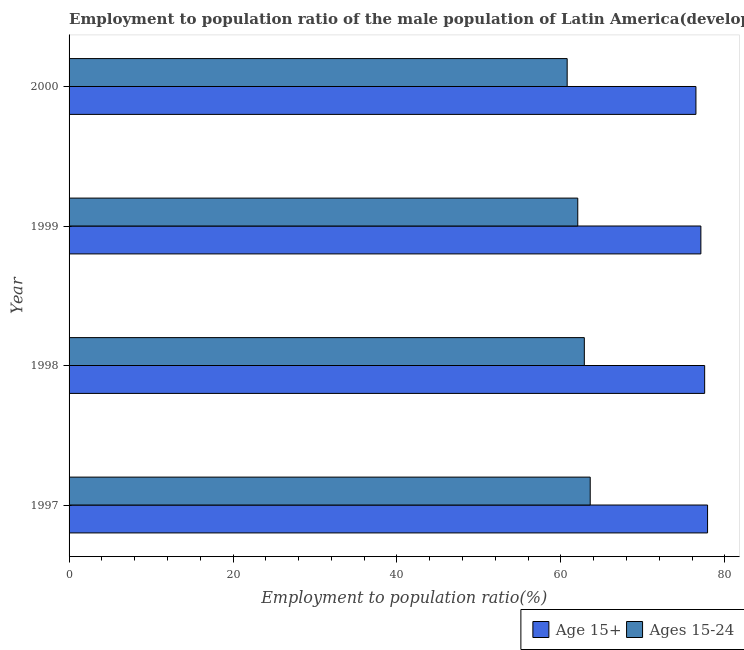How many different coloured bars are there?
Offer a terse response. 2. How many groups of bars are there?
Offer a terse response. 4. Are the number of bars per tick equal to the number of legend labels?
Offer a terse response. Yes. Are the number of bars on each tick of the Y-axis equal?
Your answer should be very brief. Yes. How many bars are there on the 4th tick from the top?
Give a very brief answer. 2. In how many cases, is the number of bars for a given year not equal to the number of legend labels?
Ensure brevity in your answer.  0. What is the employment to population ratio(age 15-24) in 1998?
Offer a terse response. 62.85. Across all years, what is the maximum employment to population ratio(age 15+)?
Ensure brevity in your answer.  77.89. Across all years, what is the minimum employment to population ratio(age 15-24)?
Offer a very short reply. 60.76. In which year was the employment to population ratio(age 15+) maximum?
Make the answer very short. 1997. What is the total employment to population ratio(age 15+) in the graph?
Provide a succinct answer. 308.96. What is the difference between the employment to population ratio(age 15+) in 1998 and that in 2000?
Keep it short and to the point. 1.06. What is the difference between the employment to population ratio(age 15+) in 1998 and the employment to population ratio(age 15-24) in 1999?
Give a very brief answer. 15.48. What is the average employment to population ratio(age 15-24) per year?
Offer a terse response. 62.31. In the year 1998, what is the difference between the employment to population ratio(age 15-24) and employment to population ratio(age 15+)?
Offer a terse response. -14.68. Is the employment to population ratio(age 15+) in 1997 less than that in 1998?
Give a very brief answer. No. What is the difference between the highest and the second highest employment to population ratio(age 15+)?
Your answer should be very brief. 0.36. What is the difference between the highest and the lowest employment to population ratio(age 15-24)?
Keep it short and to the point. 2.81. In how many years, is the employment to population ratio(age 15+) greater than the average employment to population ratio(age 15+) taken over all years?
Offer a very short reply. 2. What does the 1st bar from the top in 1999 represents?
Keep it short and to the point. Ages 15-24. What does the 1st bar from the bottom in 1997 represents?
Your response must be concise. Age 15+. How many years are there in the graph?
Your answer should be very brief. 4. Are the values on the major ticks of X-axis written in scientific E-notation?
Provide a short and direct response. No. Does the graph contain any zero values?
Provide a succinct answer. No. How are the legend labels stacked?
Give a very brief answer. Horizontal. What is the title of the graph?
Provide a succinct answer. Employment to population ratio of the male population of Latin America(developing only) for different age-groups. Does "Drinking water services" appear as one of the legend labels in the graph?
Provide a succinct answer. No. What is the label or title of the X-axis?
Offer a very short reply. Employment to population ratio(%). What is the Employment to population ratio(%) in Age 15+ in 1997?
Make the answer very short. 77.89. What is the Employment to population ratio(%) of Ages 15-24 in 1997?
Offer a very short reply. 63.57. What is the Employment to population ratio(%) of Age 15+ in 1998?
Provide a succinct answer. 77.53. What is the Employment to population ratio(%) of Ages 15-24 in 1998?
Keep it short and to the point. 62.85. What is the Employment to population ratio(%) in Age 15+ in 1999?
Your answer should be compact. 77.07. What is the Employment to population ratio(%) in Ages 15-24 in 1999?
Keep it short and to the point. 62.05. What is the Employment to population ratio(%) in Age 15+ in 2000?
Give a very brief answer. 76.47. What is the Employment to population ratio(%) in Ages 15-24 in 2000?
Your response must be concise. 60.76. Across all years, what is the maximum Employment to population ratio(%) in Age 15+?
Your answer should be compact. 77.89. Across all years, what is the maximum Employment to population ratio(%) in Ages 15-24?
Provide a short and direct response. 63.57. Across all years, what is the minimum Employment to population ratio(%) of Age 15+?
Give a very brief answer. 76.47. Across all years, what is the minimum Employment to population ratio(%) of Ages 15-24?
Offer a very short reply. 60.76. What is the total Employment to population ratio(%) in Age 15+ in the graph?
Your response must be concise. 308.96. What is the total Employment to population ratio(%) in Ages 15-24 in the graph?
Offer a very short reply. 249.24. What is the difference between the Employment to population ratio(%) of Age 15+ in 1997 and that in 1998?
Ensure brevity in your answer.  0.36. What is the difference between the Employment to population ratio(%) of Ages 15-24 in 1997 and that in 1998?
Ensure brevity in your answer.  0.72. What is the difference between the Employment to population ratio(%) in Age 15+ in 1997 and that in 1999?
Your answer should be compact. 0.82. What is the difference between the Employment to population ratio(%) of Ages 15-24 in 1997 and that in 1999?
Provide a succinct answer. 1.52. What is the difference between the Employment to population ratio(%) in Age 15+ in 1997 and that in 2000?
Your answer should be compact. 1.42. What is the difference between the Employment to population ratio(%) of Ages 15-24 in 1997 and that in 2000?
Your answer should be very brief. 2.81. What is the difference between the Employment to population ratio(%) of Age 15+ in 1998 and that in 1999?
Provide a short and direct response. 0.46. What is the difference between the Employment to population ratio(%) in Ages 15-24 in 1998 and that in 1999?
Make the answer very short. 0.8. What is the difference between the Employment to population ratio(%) in Ages 15-24 in 1998 and that in 2000?
Offer a terse response. 2.09. What is the difference between the Employment to population ratio(%) in Age 15+ in 1999 and that in 2000?
Keep it short and to the point. 0.6. What is the difference between the Employment to population ratio(%) in Ages 15-24 in 1999 and that in 2000?
Keep it short and to the point. 1.29. What is the difference between the Employment to population ratio(%) of Age 15+ in 1997 and the Employment to population ratio(%) of Ages 15-24 in 1998?
Your response must be concise. 15.03. What is the difference between the Employment to population ratio(%) of Age 15+ in 1997 and the Employment to population ratio(%) of Ages 15-24 in 1999?
Provide a short and direct response. 15.83. What is the difference between the Employment to population ratio(%) of Age 15+ in 1997 and the Employment to population ratio(%) of Ages 15-24 in 2000?
Give a very brief answer. 17.13. What is the difference between the Employment to population ratio(%) of Age 15+ in 1998 and the Employment to population ratio(%) of Ages 15-24 in 1999?
Offer a terse response. 15.48. What is the difference between the Employment to population ratio(%) of Age 15+ in 1998 and the Employment to population ratio(%) of Ages 15-24 in 2000?
Provide a short and direct response. 16.77. What is the difference between the Employment to population ratio(%) in Age 15+ in 1999 and the Employment to population ratio(%) in Ages 15-24 in 2000?
Provide a short and direct response. 16.31. What is the average Employment to population ratio(%) in Age 15+ per year?
Provide a succinct answer. 77.24. What is the average Employment to population ratio(%) in Ages 15-24 per year?
Offer a very short reply. 62.31. In the year 1997, what is the difference between the Employment to population ratio(%) in Age 15+ and Employment to population ratio(%) in Ages 15-24?
Offer a very short reply. 14.31. In the year 1998, what is the difference between the Employment to population ratio(%) of Age 15+ and Employment to population ratio(%) of Ages 15-24?
Keep it short and to the point. 14.68. In the year 1999, what is the difference between the Employment to population ratio(%) of Age 15+ and Employment to population ratio(%) of Ages 15-24?
Give a very brief answer. 15.02. In the year 2000, what is the difference between the Employment to population ratio(%) in Age 15+ and Employment to population ratio(%) in Ages 15-24?
Keep it short and to the point. 15.71. What is the ratio of the Employment to population ratio(%) in Age 15+ in 1997 to that in 1998?
Your answer should be very brief. 1. What is the ratio of the Employment to population ratio(%) in Ages 15-24 in 1997 to that in 1998?
Provide a short and direct response. 1.01. What is the ratio of the Employment to population ratio(%) of Age 15+ in 1997 to that in 1999?
Ensure brevity in your answer.  1.01. What is the ratio of the Employment to population ratio(%) in Ages 15-24 in 1997 to that in 1999?
Your answer should be compact. 1.02. What is the ratio of the Employment to population ratio(%) in Age 15+ in 1997 to that in 2000?
Your answer should be compact. 1.02. What is the ratio of the Employment to population ratio(%) in Ages 15-24 in 1997 to that in 2000?
Offer a terse response. 1.05. What is the ratio of the Employment to population ratio(%) in Age 15+ in 1998 to that in 1999?
Keep it short and to the point. 1.01. What is the ratio of the Employment to population ratio(%) of Ages 15-24 in 1998 to that in 1999?
Your answer should be compact. 1.01. What is the ratio of the Employment to population ratio(%) of Age 15+ in 1998 to that in 2000?
Your answer should be very brief. 1.01. What is the ratio of the Employment to population ratio(%) in Ages 15-24 in 1998 to that in 2000?
Keep it short and to the point. 1.03. What is the ratio of the Employment to population ratio(%) of Age 15+ in 1999 to that in 2000?
Ensure brevity in your answer.  1.01. What is the ratio of the Employment to population ratio(%) in Ages 15-24 in 1999 to that in 2000?
Your answer should be compact. 1.02. What is the difference between the highest and the second highest Employment to population ratio(%) of Age 15+?
Your answer should be very brief. 0.36. What is the difference between the highest and the second highest Employment to population ratio(%) in Ages 15-24?
Offer a very short reply. 0.72. What is the difference between the highest and the lowest Employment to population ratio(%) of Age 15+?
Provide a short and direct response. 1.42. What is the difference between the highest and the lowest Employment to population ratio(%) of Ages 15-24?
Provide a succinct answer. 2.81. 